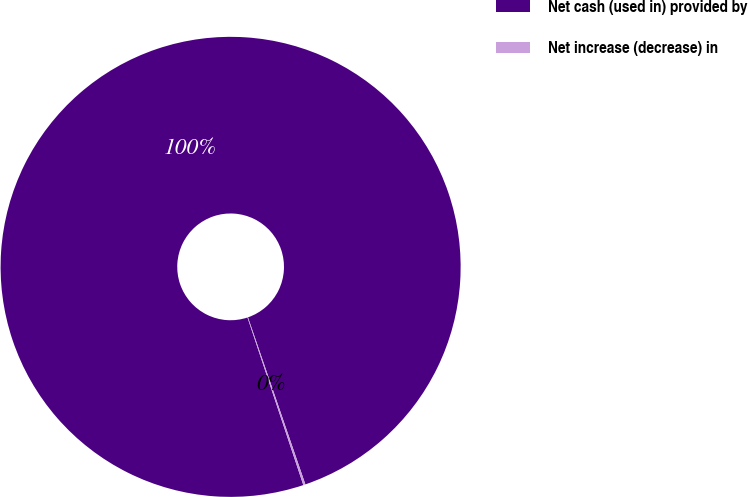<chart> <loc_0><loc_0><loc_500><loc_500><pie_chart><fcel>Net cash (used in) provided by<fcel>Net increase (decrease) in<nl><fcel>99.85%<fcel>0.15%<nl></chart> 